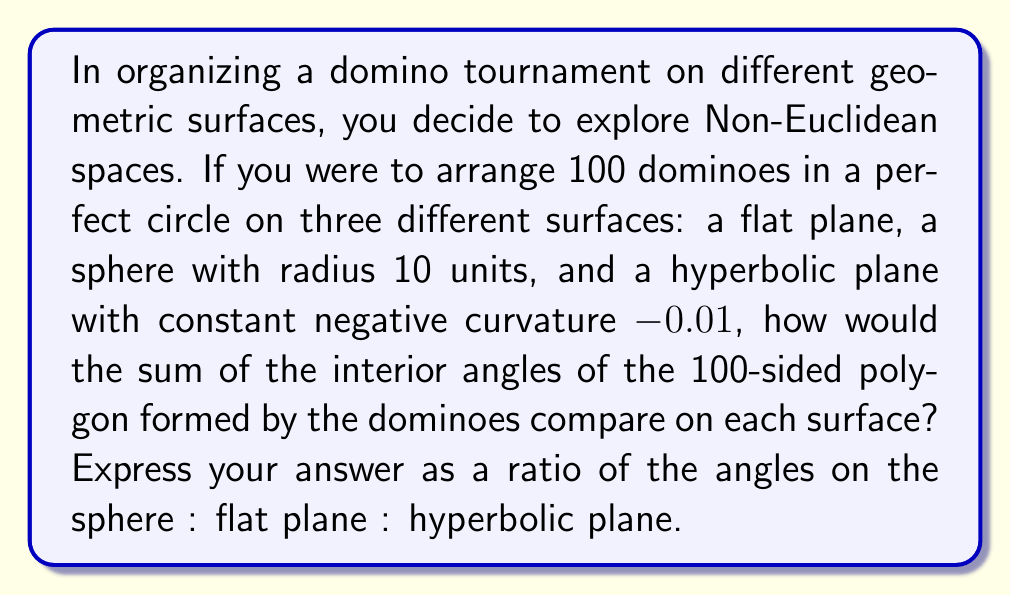Could you help me with this problem? Let's approach this step-by-step:

1) For a polygon with n sides:
   - On a flat plane (Euclidean geometry), the sum of interior angles is: $$(n-2) \times 180°$$
   - On a sphere (positive curvature), the sum is: $$(n-2) \times 180° + A$$, where A is the area of the polygon
   - On a hyperbolic plane (negative curvature), the sum is: $$(n-2) \times 180° - A$$, where A is the area of the polygon

2) In our case, n = 100

3) For the flat plane:
   Sum = $(100-2) \times 180° = 17,640°$

4) For the sphere:
   - The area of a circle on a sphere is: $$A = 4\pi r^2 \sin^2(\frac{\theta}{2})$$
     where $\theta$ is the angular radius of the circle
   - For a large circle (assuming our 100 dominoes form a great circle), $\theta = \pi$
   - Thus, $A = 4\pi r^2 = 4\pi \times 10^2 = 400\pi$
   - Sum on sphere = $17,640° + 400\pi° \approx 18,897.4°$

5) For the hyperbolic plane:
   - The area of a circle in hyperbolic geometry is:
     $$A = 4\pi \sinh^2(\frac{r}{2})$$
     where r is the radius of the circle
   - Assuming the dominoes form a circle with radius 10:
     $$A = 4\pi \sinh^2(5) \approx 5,986.2$$
   - Sum on hyperbolic plane = $17,640° - 5,986.2° \approx 11,653.8°$

6) Ratio of angles:
   Sphere : Flat : Hyperbolic
   $18,897.4 : 17,640 : 11,653.8$

7) Simplifying the ratio:
   $1.071 : 1 : 0.661$
Answer: $1.071 : 1 : 0.661$ 